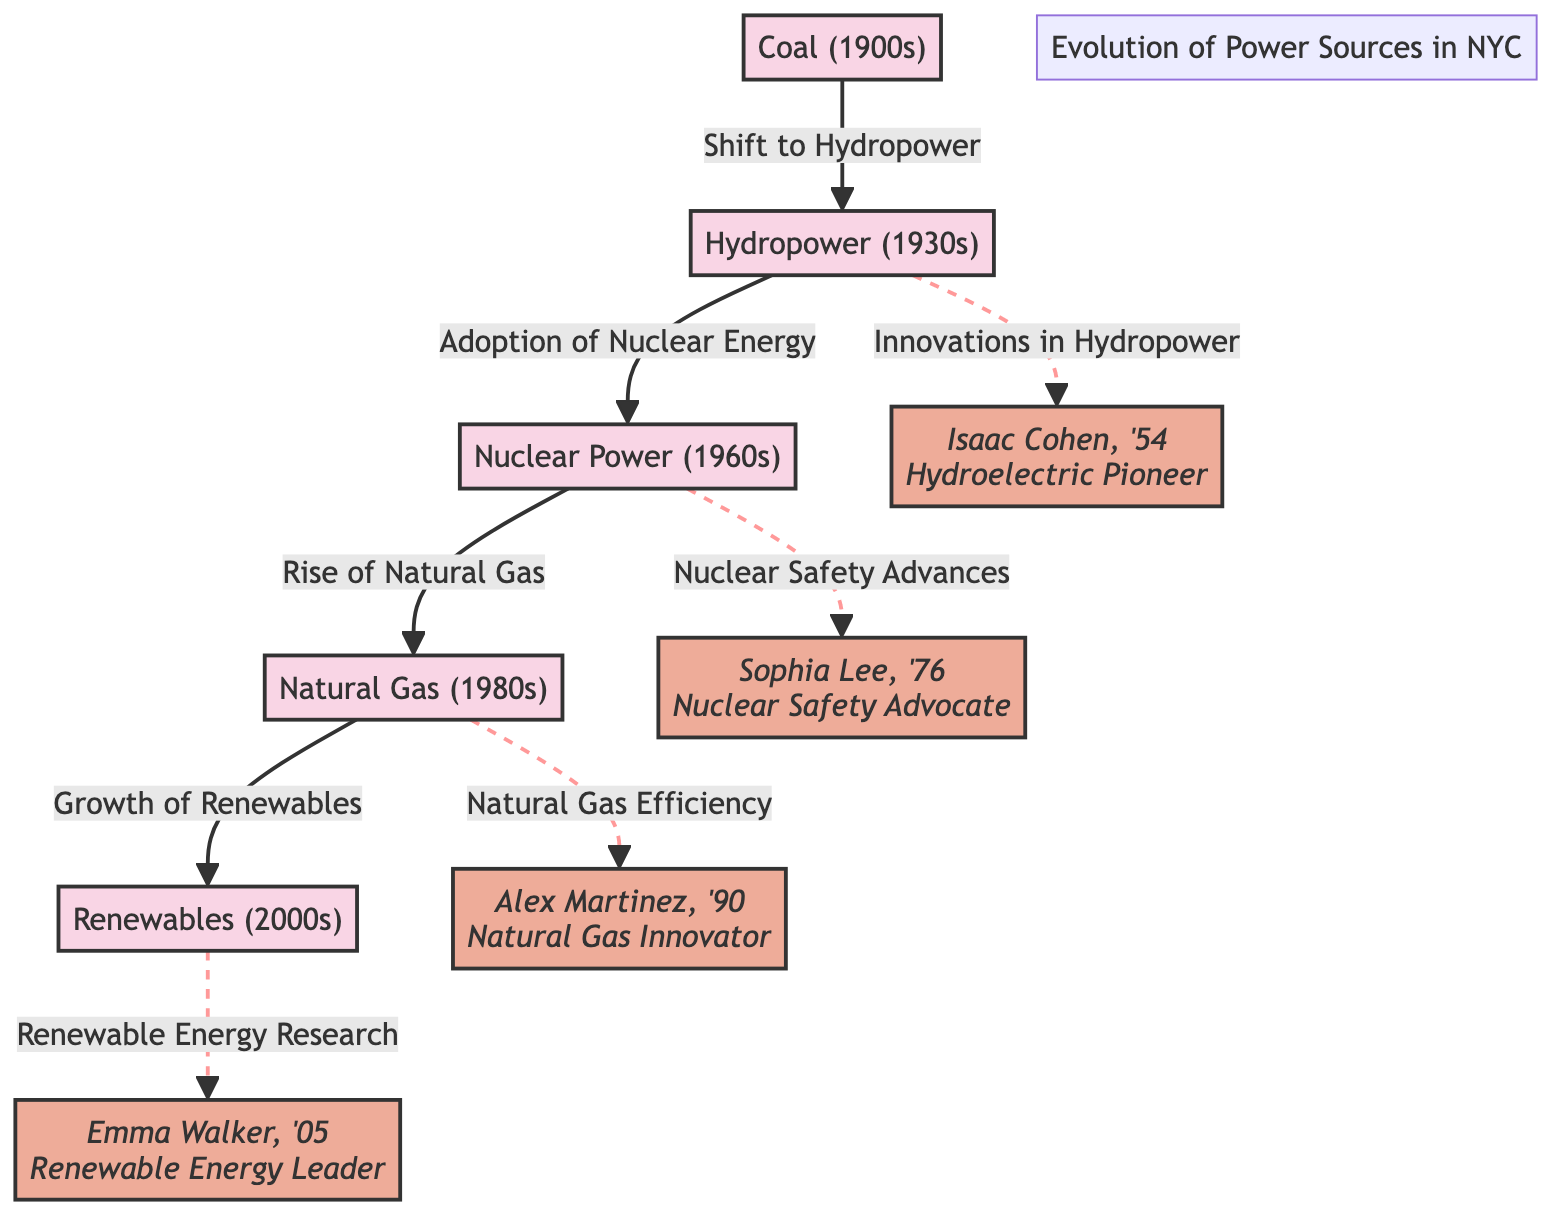What power source was dominant in the 1900s? The diagram shows that "Coal" is indicated as the primary power source for the 1900s. This is directly stated in the node labeled "Coal (1900s)."
Answer: Coal (1900s) What is the relationship between Hydropower and Nuclear Power? The diagram depicts a direct flow from "Hydropower (1930s)" to "Nuclear Power (1960s)", indicating that Hydropower was succeeded by Nuclear Power. This is indicated by the arrow labeled "Adoption of Nuclear Energy."
Answer: Adoption of Nuclear Energy How many power sources are listed in the diagram? Counting the power sources mentioned in the diagram, we see five distinct sources: Coal, Hydropower, Nuclear Power, Natural Gas, and Renewables, as indicated in their respective nodes.
Answer: 5 Who is associated with innovations in Hydropower? The diagram explicitly states that "Isaac Cohen, '54" is the alumnus associated with innovations in Hydropower, connected with a dashed line to "Hydropower (1930s)."
Answer: Isaac Cohen Which power source does Natural Gas transition to? According to the diagram, "Natural Gas (1980s)" leads to "Renewables (2000s)," which is illustrated by a direct flow indicating transition, labeled "Growth of Renewables."
Answer: Renewables (2000s) What contributions is Sophia Lee known for? The diagram indicates that "Sophia Lee, '76" is recognized for "Nuclear Safety Advances," as represented with a dashed line leading from "Nuclear Power (1960s)."
Answer: Nuclear Safety Advances What kind of relationship is depicted between Natural Gas and its efficiency? A dashed line connects "Natural Gas (1980s)" to Alex Martinez, signifying a relationship characterized by innovation in efficiency, as labeled "Natural Gas Efficiency."
Answer: Natural Gas Efficiency What decade saw the introduction of Renewables? The diagram shows that "Renewables" are listed under the 2000s as their specific decade, directly indicated in the node labeled "Renewables (2000s)."
Answer: 2000s 